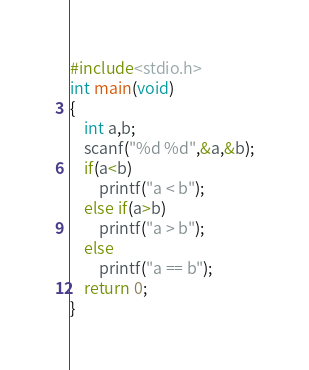<code> <loc_0><loc_0><loc_500><loc_500><_C_>#include<stdio.h>
int main(void)
{
    int a,b;
    scanf("%d %d",&a,&b);
    if(a<b)
        printf("a < b");
    else if(a>b) 
        printf("a > b");
    else 
        printf("a == b");
    return 0;
}</code> 